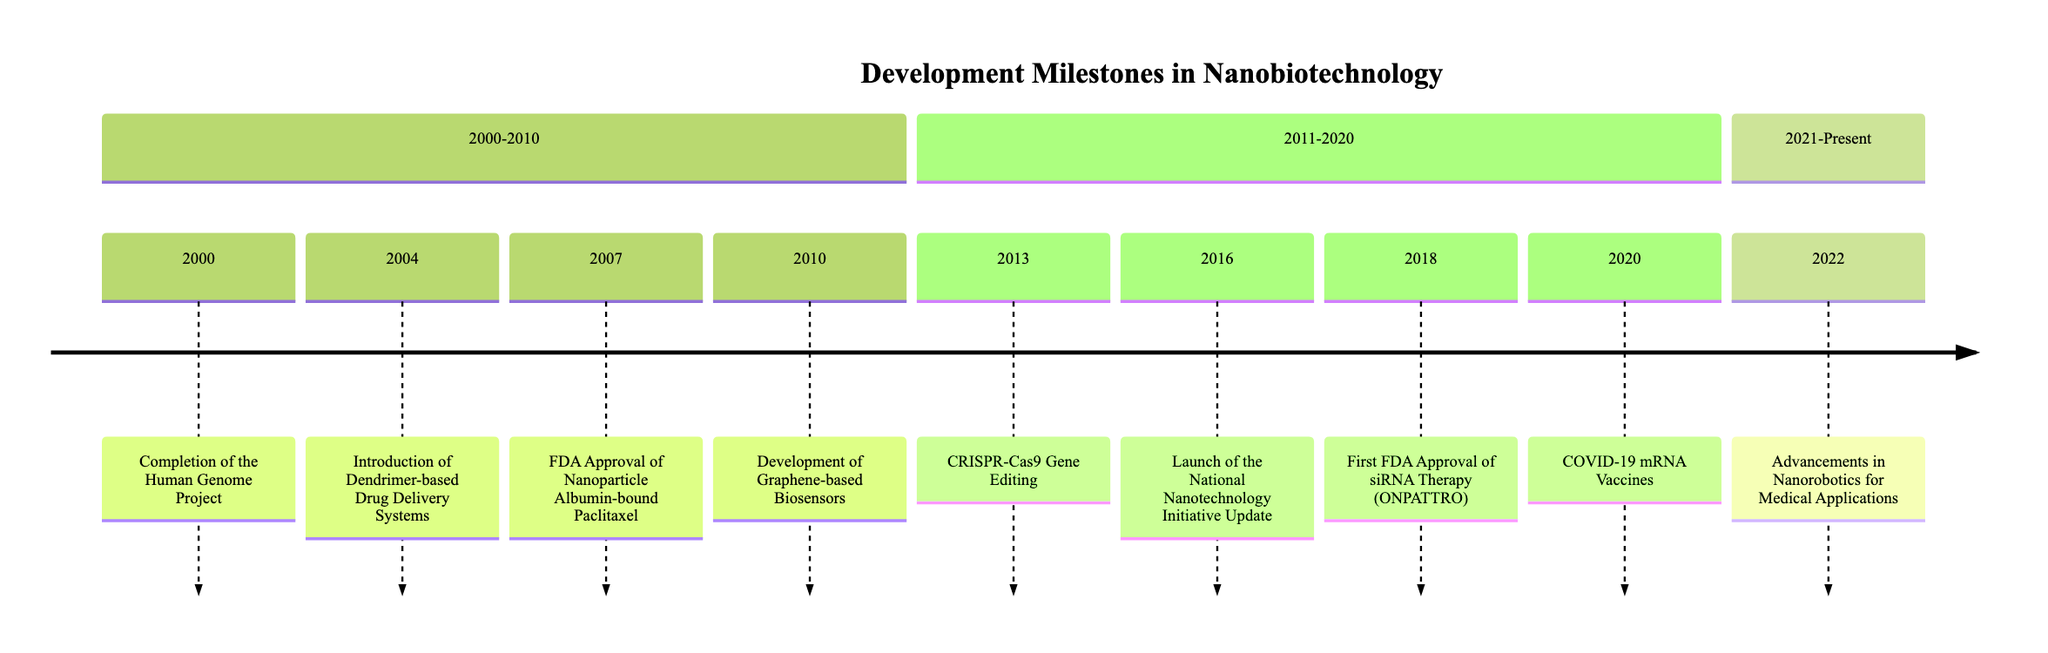What milestone occurred in 2000? The diagram indicates that the milestone in 2000 is the "Completion of the Human Genome Project." This information is found directly at the year node labeled "2000."
Answer: Completion of the Human Genome Project How many milestones are listed between 2011 and 2020? The diagram shows four milestones listed in the section from 2011 to 2020. Specifically, they are the CRISPR-Cas9 Gene Editing (2013), Launch of the National Nanotechnology Initiative Update (2016), First FDA Approval of siRNA Therapy (ONPATTRO) (2018), and COVID-19 mRNA Vaccines (2020). Counting these gives a total of four milestones.
Answer: 4 What was introduced in 2004? The timeline indicates that the introduction in 2004 is "Dendrimer-based Drug Delivery Systems." This information is found at the node labeled "2004."
Answer: Dendrimer-based Drug Delivery Systems Which milestone highlights advancements in medical nanorobotics? According to the timeline, the milestone that highlights advancements in medical nanorobotics is from 2022, noted as "Advancements in Nanorobotics for Medical Applications." This can be identified by locating the year 2022 on the timeline.
Answer: Advancements in Nanorobotics for Medical Applications When did the FDA approve a nanoparticle-based treatment? The diagram states that the FDA approved a nanoparticle-based treatment in 2007, specifically "Nanoparticle Albumin-bound Paclitaxel (Abraxane)." This information can be verified by examining the entry for the year 2007.
Answer: 2007 What significant event did the year 2013 mark in this timeline? The year 2013 is marked by the milestone "CRISPR-Cas9 Gene Editing." To find this, one would look at the corresponding node under the 2011-2020 section.
Answer: CRISPR-Cas9 Gene Editing What unique delivery system was utilized in the COVID-19 vaccines? The diagram indicates that lipid nanoparticles were utilized for delivery in the COVID-19 mRNA Vaccines. This detail is presented alongside the milestone for 2020.
Answer: Lipid nanoparticles How many milestones are listed overall from 2000 to 2022? In total, the diagram lists eight milestones from the years 2000 to 2022. This can be determined by counting all the milestones across the three sections of the timeline.
Answer: 8 